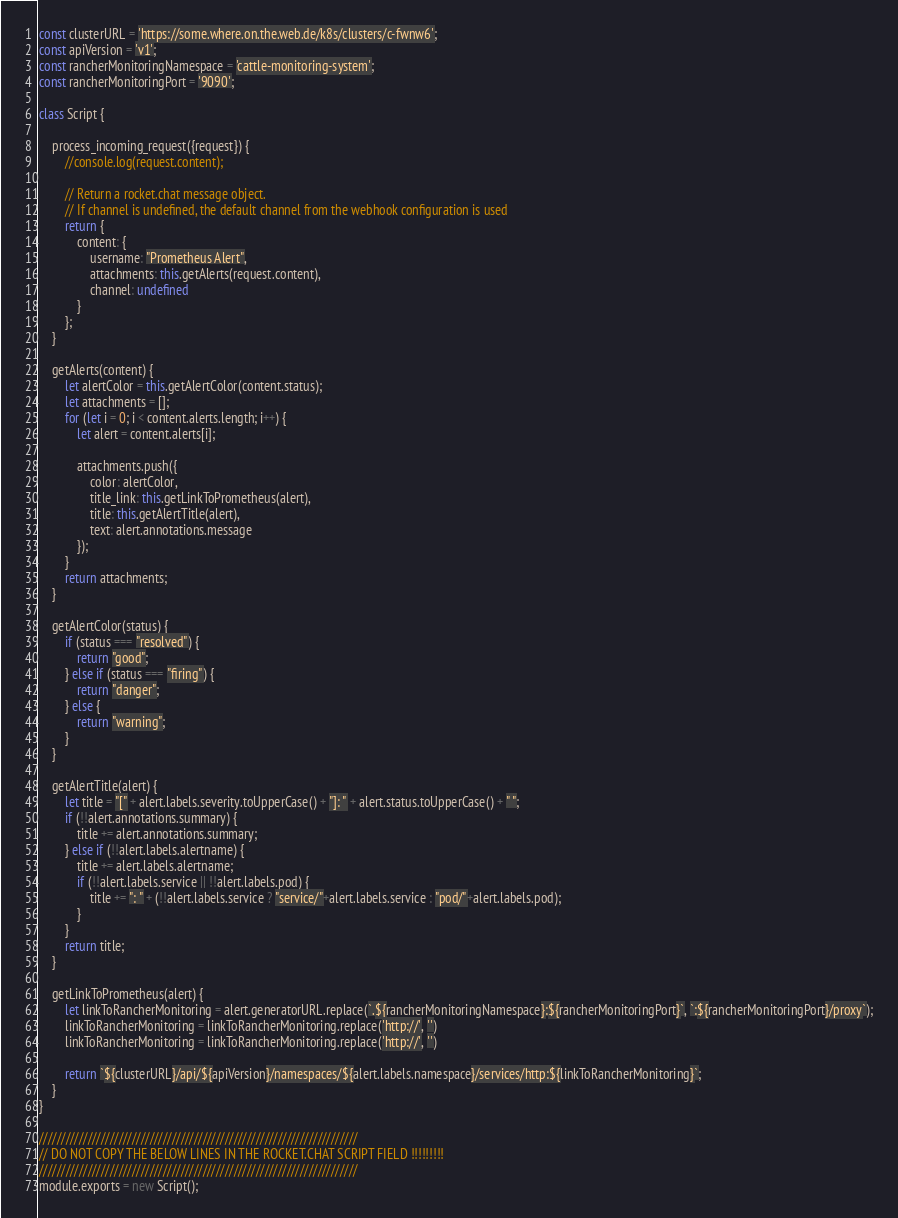<code> <loc_0><loc_0><loc_500><loc_500><_JavaScript_>const clusterURL = 'https://some.where.on.the.web.de/k8s/clusters/c-fwnw6';
const apiVersion = 'v1';
const rancherMonitoringNamespace = 'cattle-monitoring-system';
const rancherMonitoringPort = '9090';

class Script {

    process_incoming_request({request}) {
        //console.log(request.content);

        // Return a rocket.chat message object.
        // If channel is undefined, the default channel from the webhook configuration is used
        return {
            content: {
                username: "Prometheus Alert",
                attachments: this.getAlerts(request.content),
                channel: undefined
            }
        };
    }

    getAlerts(content) {
        let alertColor = this.getAlertColor(content.status);
        let attachments = [];
        for (let i = 0; i < content.alerts.length; i++) {
            let alert = content.alerts[i];

            attachments.push({
                color: alertColor,
                title_link: this.getLinkToPrometheus(alert),
                title: this.getAlertTitle(alert),
                text: alert.annotations.message
            });
        }
        return attachments;
    }

    getAlertColor(status) {
        if (status === "resolved") {
            return "good";
        } else if (status === "firing") {
            return "danger";
        } else {
            return "warning";
        }
    }

    getAlertTitle(alert) {
        let title = "[" + alert.labels.severity.toUpperCase() + "]: " + alert.status.toUpperCase() + " ";
        if (!!alert.annotations.summary) {
            title += alert.annotations.summary;
        } else if (!!alert.labels.alertname) {
            title += alert.labels.alertname;
            if (!!alert.labels.service || !!alert.labels.pod) {
                title += ": " + (!!alert.labels.service ? "service/"+alert.labels.service : "pod/"+alert.labels.pod);
            }
        }
        return title;
    }

    getLinkToPrometheus(alert) {
        let linkToRancherMonitoring = alert.generatorURL.replace(`.${rancherMonitoringNamespace}:${rancherMonitoringPort}`, `:${rancherMonitoringPort}/proxy`);
        linkToRancherMonitoring = linkToRancherMonitoring.replace('http://', '')
        linkToRancherMonitoring = linkToRancherMonitoring.replace('http://', '')

        return `${clusterURL}/api/${apiVersion}/namespaces/${alert.labels.namespace}/services/http:${linkToRancherMonitoring}`;
    }
}

////////////////////////////////////////////////////////////////////////
// DO NOT COPY THE BELOW LINES IN THE ROCKET.CHAT SCRIPT FIELD !!!!!!!!!
////////////////////////////////////////////////////////////////////////
module.exports = new Script();</code> 